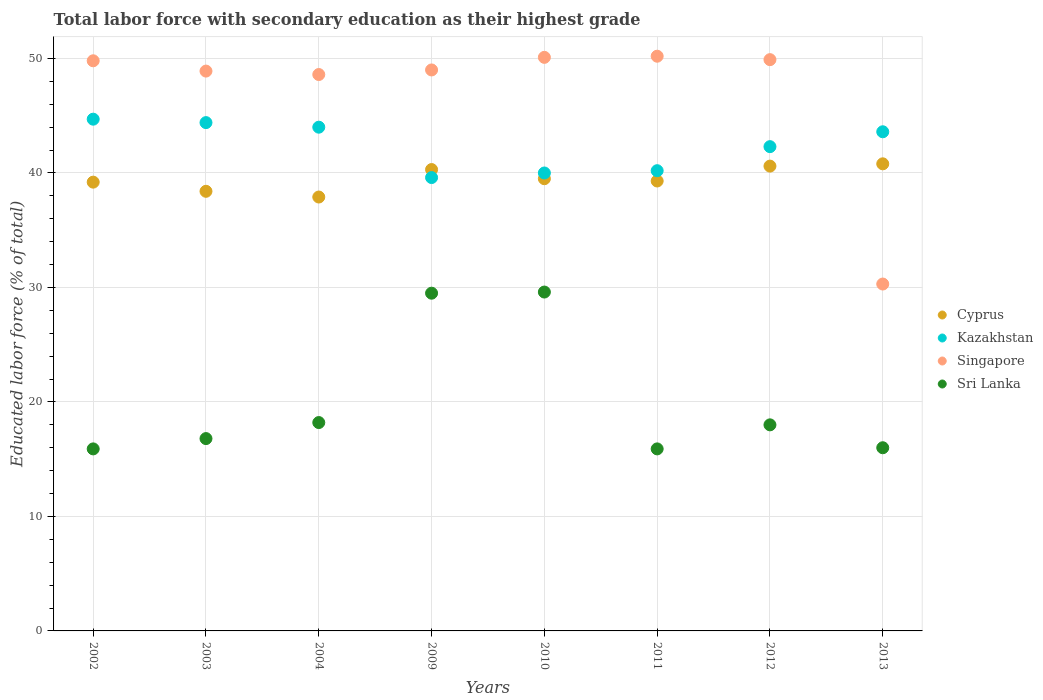How many different coloured dotlines are there?
Provide a short and direct response. 4. Is the number of dotlines equal to the number of legend labels?
Your answer should be very brief. Yes. Across all years, what is the maximum percentage of total labor force with primary education in Singapore?
Ensure brevity in your answer.  50.2. Across all years, what is the minimum percentage of total labor force with primary education in Sri Lanka?
Your answer should be very brief. 15.9. In which year was the percentage of total labor force with primary education in Singapore maximum?
Your response must be concise. 2011. In which year was the percentage of total labor force with primary education in Sri Lanka minimum?
Offer a very short reply. 2002. What is the total percentage of total labor force with primary education in Cyprus in the graph?
Offer a very short reply. 316. What is the difference between the percentage of total labor force with primary education in Cyprus in 2002 and that in 2003?
Offer a very short reply. 0.8. What is the difference between the percentage of total labor force with primary education in Singapore in 2003 and the percentage of total labor force with primary education in Kazakhstan in 2012?
Offer a very short reply. 6.6. What is the average percentage of total labor force with primary education in Kazakhstan per year?
Offer a very short reply. 42.35. In the year 2011, what is the difference between the percentage of total labor force with primary education in Cyprus and percentage of total labor force with primary education in Sri Lanka?
Offer a very short reply. 23.4. In how many years, is the percentage of total labor force with primary education in Sri Lanka greater than 32 %?
Offer a terse response. 0. What is the ratio of the percentage of total labor force with primary education in Sri Lanka in 2002 to that in 2004?
Give a very brief answer. 0.87. Is the percentage of total labor force with primary education in Sri Lanka in 2011 less than that in 2013?
Your answer should be compact. Yes. Is the difference between the percentage of total labor force with primary education in Cyprus in 2002 and 2011 greater than the difference between the percentage of total labor force with primary education in Sri Lanka in 2002 and 2011?
Make the answer very short. No. What is the difference between the highest and the second highest percentage of total labor force with primary education in Cyprus?
Ensure brevity in your answer.  0.2. What is the difference between the highest and the lowest percentage of total labor force with primary education in Sri Lanka?
Your answer should be very brief. 13.7. In how many years, is the percentage of total labor force with primary education in Sri Lanka greater than the average percentage of total labor force with primary education in Sri Lanka taken over all years?
Ensure brevity in your answer.  2. Is it the case that in every year, the sum of the percentage of total labor force with primary education in Singapore and percentage of total labor force with primary education in Kazakhstan  is greater than the percentage of total labor force with primary education in Sri Lanka?
Provide a short and direct response. Yes. Is the percentage of total labor force with primary education in Singapore strictly less than the percentage of total labor force with primary education in Kazakhstan over the years?
Your answer should be very brief. No. How many dotlines are there?
Ensure brevity in your answer.  4. How many years are there in the graph?
Provide a succinct answer. 8. Does the graph contain any zero values?
Your response must be concise. No. How many legend labels are there?
Give a very brief answer. 4. How are the legend labels stacked?
Provide a short and direct response. Vertical. What is the title of the graph?
Your answer should be compact. Total labor force with secondary education as their highest grade. What is the label or title of the Y-axis?
Ensure brevity in your answer.  Educated labor force (% of total). What is the Educated labor force (% of total) in Cyprus in 2002?
Your answer should be compact. 39.2. What is the Educated labor force (% of total) in Kazakhstan in 2002?
Make the answer very short. 44.7. What is the Educated labor force (% of total) in Singapore in 2002?
Offer a terse response. 49.8. What is the Educated labor force (% of total) in Sri Lanka in 2002?
Your response must be concise. 15.9. What is the Educated labor force (% of total) in Cyprus in 2003?
Keep it short and to the point. 38.4. What is the Educated labor force (% of total) in Kazakhstan in 2003?
Your response must be concise. 44.4. What is the Educated labor force (% of total) in Singapore in 2003?
Your answer should be compact. 48.9. What is the Educated labor force (% of total) in Sri Lanka in 2003?
Make the answer very short. 16.8. What is the Educated labor force (% of total) in Cyprus in 2004?
Keep it short and to the point. 37.9. What is the Educated labor force (% of total) in Singapore in 2004?
Your answer should be very brief. 48.6. What is the Educated labor force (% of total) in Sri Lanka in 2004?
Your response must be concise. 18.2. What is the Educated labor force (% of total) in Cyprus in 2009?
Your answer should be very brief. 40.3. What is the Educated labor force (% of total) of Kazakhstan in 2009?
Ensure brevity in your answer.  39.6. What is the Educated labor force (% of total) of Sri Lanka in 2009?
Offer a terse response. 29.5. What is the Educated labor force (% of total) in Cyprus in 2010?
Provide a succinct answer. 39.5. What is the Educated labor force (% of total) of Kazakhstan in 2010?
Your response must be concise. 40. What is the Educated labor force (% of total) in Singapore in 2010?
Keep it short and to the point. 50.1. What is the Educated labor force (% of total) in Sri Lanka in 2010?
Your answer should be very brief. 29.6. What is the Educated labor force (% of total) in Cyprus in 2011?
Provide a short and direct response. 39.3. What is the Educated labor force (% of total) in Kazakhstan in 2011?
Ensure brevity in your answer.  40.2. What is the Educated labor force (% of total) of Singapore in 2011?
Provide a short and direct response. 50.2. What is the Educated labor force (% of total) in Sri Lanka in 2011?
Offer a very short reply. 15.9. What is the Educated labor force (% of total) of Cyprus in 2012?
Ensure brevity in your answer.  40.6. What is the Educated labor force (% of total) in Kazakhstan in 2012?
Provide a short and direct response. 42.3. What is the Educated labor force (% of total) of Singapore in 2012?
Ensure brevity in your answer.  49.9. What is the Educated labor force (% of total) of Cyprus in 2013?
Your answer should be very brief. 40.8. What is the Educated labor force (% of total) in Kazakhstan in 2013?
Offer a very short reply. 43.6. What is the Educated labor force (% of total) in Singapore in 2013?
Your response must be concise. 30.3. Across all years, what is the maximum Educated labor force (% of total) in Cyprus?
Make the answer very short. 40.8. Across all years, what is the maximum Educated labor force (% of total) in Kazakhstan?
Keep it short and to the point. 44.7. Across all years, what is the maximum Educated labor force (% of total) in Singapore?
Your response must be concise. 50.2. Across all years, what is the maximum Educated labor force (% of total) in Sri Lanka?
Give a very brief answer. 29.6. Across all years, what is the minimum Educated labor force (% of total) in Cyprus?
Offer a very short reply. 37.9. Across all years, what is the minimum Educated labor force (% of total) in Kazakhstan?
Make the answer very short. 39.6. Across all years, what is the minimum Educated labor force (% of total) in Singapore?
Your answer should be compact. 30.3. Across all years, what is the minimum Educated labor force (% of total) in Sri Lanka?
Your answer should be compact. 15.9. What is the total Educated labor force (% of total) in Cyprus in the graph?
Your response must be concise. 316. What is the total Educated labor force (% of total) of Kazakhstan in the graph?
Keep it short and to the point. 338.8. What is the total Educated labor force (% of total) of Singapore in the graph?
Your answer should be compact. 376.8. What is the total Educated labor force (% of total) of Sri Lanka in the graph?
Provide a short and direct response. 159.9. What is the difference between the Educated labor force (% of total) of Kazakhstan in 2002 and that in 2003?
Make the answer very short. 0.3. What is the difference between the Educated labor force (% of total) in Sri Lanka in 2002 and that in 2003?
Ensure brevity in your answer.  -0.9. What is the difference between the Educated labor force (% of total) in Cyprus in 2002 and that in 2004?
Provide a succinct answer. 1.3. What is the difference between the Educated labor force (% of total) in Singapore in 2002 and that in 2004?
Provide a succinct answer. 1.2. What is the difference between the Educated labor force (% of total) of Cyprus in 2002 and that in 2009?
Keep it short and to the point. -1.1. What is the difference between the Educated labor force (% of total) of Singapore in 2002 and that in 2009?
Provide a short and direct response. 0.8. What is the difference between the Educated labor force (% of total) of Kazakhstan in 2002 and that in 2010?
Provide a succinct answer. 4.7. What is the difference between the Educated labor force (% of total) in Singapore in 2002 and that in 2010?
Offer a very short reply. -0.3. What is the difference between the Educated labor force (% of total) in Sri Lanka in 2002 and that in 2010?
Your response must be concise. -13.7. What is the difference between the Educated labor force (% of total) of Cyprus in 2002 and that in 2011?
Provide a short and direct response. -0.1. What is the difference between the Educated labor force (% of total) in Kazakhstan in 2002 and that in 2011?
Make the answer very short. 4.5. What is the difference between the Educated labor force (% of total) of Singapore in 2002 and that in 2011?
Your answer should be very brief. -0.4. What is the difference between the Educated labor force (% of total) of Cyprus in 2002 and that in 2013?
Provide a succinct answer. -1.6. What is the difference between the Educated labor force (% of total) in Singapore in 2003 and that in 2004?
Ensure brevity in your answer.  0.3. What is the difference between the Educated labor force (% of total) of Sri Lanka in 2003 and that in 2004?
Your response must be concise. -1.4. What is the difference between the Educated labor force (% of total) of Kazakhstan in 2003 and that in 2009?
Offer a terse response. 4.8. What is the difference between the Educated labor force (% of total) of Kazakhstan in 2003 and that in 2010?
Make the answer very short. 4.4. What is the difference between the Educated labor force (% of total) in Singapore in 2003 and that in 2010?
Your answer should be very brief. -1.2. What is the difference between the Educated labor force (% of total) of Sri Lanka in 2003 and that in 2010?
Keep it short and to the point. -12.8. What is the difference between the Educated labor force (% of total) of Cyprus in 2003 and that in 2011?
Keep it short and to the point. -0.9. What is the difference between the Educated labor force (% of total) of Sri Lanka in 2003 and that in 2011?
Your answer should be very brief. 0.9. What is the difference between the Educated labor force (% of total) in Singapore in 2003 and that in 2012?
Your answer should be compact. -1. What is the difference between the Educated labor force (% of total) of Sri Lanka in 2003 and that in 2012?
Your answer should be very brief. -1.2. What is the difference between the Educated labor force (% of total) of Cyprus in 2004 and that in 2009?
Make the answer very short. -2.4. What is the difference between the Educated labor force (% of total) of Kazakhstan in 2004 and that in 2009?
Give a very brief answer. 4.4. What is the difference between the Educated labor force (% of total) of Singapore in 2004 and that in 2009?
Offer a very short reply. -0.4. What is the difference between the Educated labor force (% of total) in Singapore in 2004 and that in 2010?
Give a very brief answer. -1.5. What is the difference between the Educated labor force (% of total) in Singapore in 2004 and that in 2011?
Keep it short and to the point. -1.6. What is the difference between the Educated labor force (% of total) in Sri Lanka in 2004 and that in 2011?
Your answer should be compact. 2.3. What is the difference between the Educated labor force (% of total) of Singapore in 2004 and that in 2012?
Your answer should be very brief. -1.3. What is the difference between the Educated labor force (% of total) of Sri Lanka in 2004 and that in 2012?
Provide a succinct answer. 0.2. What is the difference between the Educated labor force (% of total) of Cyprus in 2004 and that in 2013?
Give a very brief answer. -2.9. What is the difference between the Educated labor force (% of total) of Singapore in 2004 and that in 2013?
Provide a succinct answer. 18.3. What is the difference between the Educated labor force (% of total) of Singapore in 2009 and that in 2010?
Ensure brevity in your answer.  -1.1. What is the difference between the Educated labor force (% of total) in Kazakhstan in 2009 and that in 2011?
Your answer should be compact. -0.6. What is the difference between the Educated labor force (% of total) in Sri Lanka in 2009 and that in 2011?
Offer a terse response. 13.6. What is the difference between the Educated labor force (% of total) of Cyprus in 2009 and that in 2012?
Offer a very short reply. -0.3. What is the difference between the Educated labor force (% of total) in Kazakhstan in 2009 and that in 2012?
Keep it short and to the point. -2.7. What is the difference between the Educated labor force (% of total) in Cyprus in 2009 and that in 2013?
Provide a succinct answer. -0.5. What is the difference between the Educated labor force (% of total) of Kazakhstan in 2009 and that in 2013?
Your answer should be very brief. -4. What is the difference between the Educated labor force (% of total) in Singapore in 2009 and that in 2013?
Offer a terse response. 18.7. What is the difference between the Educated labor force (% of total) in Sri Lanka in 2009 and that in 2013?
Offer a terse response. 13.5. What is the difference between the Educated labor force (% of total) of Singapore in 2010 and that in 2011?
Give a very brief answer. -0.1. What is the difference between the Educated labor force (% of total) of Kazakhstan in 2010 and that in 2012?
Offer a very short reply. -2.3. What is the difference between the Educated labor force (% of total) in Kazakhstan in 2010 and that in 2013?
Offer a terse response. -3.6. What is the difference between the Educated labor force (% of total) in Singapore in 2010 and that in 2013?
Offer a terse response. 19.8. What is the difference between the Educated labor force (% of total) of Cyprus in 2011 and that in 2012?
Ensure brevity in your answer.  -1.3. What is the difference between the Educated labor force (% of total) in Kazakhstan in 2011 and that in 2012?
Offer a very short reply. -2.1. What is the difference between the Educated labor force (% of total) of Singapore in 2011 and that in 2012?
Your response must be concise. 0.3. What is the difference between the Educated labor force (% of total) in Sri Lanka in 2011 and that in 2012?
Your response must be concise. -2.1. What is the difference between the Educated labor force (% of total) in Kazakhstan in 2011 and that in 2013?
Your answer should be very brief. -3.4. What is the difference between the Educated labor force (% of total) of Singapore in 2011 and that in 2013?
Your answer should be compact. 19.9. What is the difference between the Educated labor force (% of total) of Cyprus in 2012 and that in 2013?
Provide a succinct answer. -0.2. What is the difference between the Educated labor force (% of total) in Kazakhstan in 2012 and that in 2013?
Make the answer very short. -1.3. What is the difference between the Educated labor force (% of total) in Singapore in 2012 and that in 2013?
Your answer should be compact. 19.6. What is the difference between the Educated labor force (% of total) of Sri Lanka in 2012 and that in 2013?
Offer a very short reply. 2. What is the difference between the Educated labor force (% of total) of Cyprus in 2002 and the Educated labor force (% of total) of Kazakhstan in 2003?
Your response must be concise. -5.2. What is the difference between the Educated labor force (% of total) of Cyprus in 2002 and the Educated labor force (% of total) of Singapore in 2003?
Provide a short and direct response. -9.7. What is the difference between the Educated labor force (% of total) in Cyprus in 2002 and the Educated labor force (% of total) in Sri Lanka in 2003?
Give a very brief answer. 22.4. What is the difference between the Educated labor force (% of total) of Kazakhstan in 2002 and the Educated labor force (% of total) of Sri Lanka in 2003?
Make the answer very short. 27.9. What is the difference between the Educated labor force (% of total) of Cyprus in 2002 and the Educated labor force (% of total) of Kazakhstan in 2004?
Make the answer very short. -4.8. What is the difference between the Educated labor force (% of total) of Cyprus in 2002 and the Educated labor force (% of total) of Sri Lanka in 2004?
Keep it short and to the point. 21. What is the difference between the Educated labor force (% of total) of Kazakhstan in 2002 and the Educated labor force (% of total) of Sri Lanka in 2004?
Make the answer very short. 26.5. What is the difference between the Educated labor force (% of total) in Singapore in 2002 and the Educated labor force (% of total) in Sri Lanka in 2004?
Your response must be concise. 31.6. What is the difference between the Educated labor force (% of total) of Cyprus in 2002 and the Educated labor force (% of total) of Kazakhstan in 2009?
Your answer should be very brief. -0.4. What is the difference between the Educated labor force (% of total) of Kazakhstan in 2002 and the Educated labor force (% of total) of Sri Lanka in 2009?
Provide a short and direct response. 15.2. What is the difference between the Educated labor force (% of total) of Singapore in 2002 and the Educated labor force (% of total) of Sri Lanka in 2009?
Provide a succinct answer. 20.3. What is the difference between the Educated labor force (% of total) in Kazakhstan in 2002 and the Educated labor force (% of total) in Singapore in 2010?
Make the answer very short. -5.4. What is the difference between the Educated labor force (% of total) of Singapore in 2002 and the Educated labor force (% of total) of Sri Lanka in 2010?
Provide a short and direct response. 20.2. What is the difference between the Educated labor force (% of total) in Cyprus in 2002 and the Educated labor force (% of total) in Kazakhstan in 2011?
Provide a short and direct response. -1. What is the difference between the Educated labor force (% of total) of Cyprus in 2002 and the Educated labor force (% of total) of Sri Lanka in 2011?
Your answer should be compact. 23.3. What is the difference between the Educated labor force (% of total) of Kazakhstan in 2002 and the Educated labor force (% of total) of Sri Lanka in 2011?
Offer a very short reply. 28.8. What is the difference between the Educated labor force (% of total) of Singapore in 2002 and the Educated labor force (% of total) of Sri Lanka in 2011?
Provide a succinct answer. 33.9. What is the difference between the Educated labor force (% of total) in Cyprus in 2002 and the Educated labor force (% of total) in Sri Lanka in 2012?
Give a very brief answer. 21.2. What is the difference between the Educated labor force (% of total) in Kazakhstan in 2002 and the Educated labor force (% of total) in Sri Lanka in 2012?
Offer a terse response. 26.7. What is the difference between the Educated labor force (% of total) in Singapore in 2002 and the Educated labor force (% of total) in Sri Lanka in 2012?
Make the answer very short. 31.8. What is the difference between the Educated labor force (% of total) in Cyprus in 2002 and the Educated labor force (% of total) in Kazakhstan in 2013?
Provide a succinct answer. -4.4. What is the difference between the Educated labor force (% of total) of Cyprus in 2002 and the Educated labor force (% of total) of Singapore in 2013?
Provide a short and direct response. 8.9. What is the difference between the Educated labor force (% of total) of Cyprus in 2002 and the Educated labor force (% of total) of Sri Lanka in 2013?
Provide a succinct answer. 23.2. What is the difference between the Educated labor force (% of total) of Kazakhstan in 2002 and the Educated labor force (% of total) of Singapore in 2013?
Your response must be concise. 14.4. What is the difference between the Educated labor force (% of total) in Kazakhstan in 2002 and the Educated labor force (% of total) in Sri Lanka in 2013?
Ensure brevity in your answer.  28.7. What is the difference between the Educated labor force (% of total) in Singapore in 2002 and the Educated labor force (% of total) in Sri Lanka in 2013?
Keep it short and to the point. 33.8. What is the difference between the Educated labor force (% of total) of Cyprus in 2003 and the Educated labor force (% of total) of Kazakhstan in 2004?
Your response must be concise. -5.6. What is the difference between the Educated labor force (% of total) in Cyprus in 2003 and the Educated labor force (% of total) in Sri Lanka in 2004?
Offer a terse response. 20.2. What is the difference between the Educated labor force (% of total) in Kazakhstan in 2003 and the Educated labor force (% of total) in Sri Lanka in 2004?
Provide a short and direct response. 26.2. What is the difference between the Educated labor force (% of total) in Singapore in 2003 and the Educated labor force (% of total) in Sri Lanka in 2004?
Provide a succinct answer. 30.7. What is the difference between the Educated labor force (% of total) in Cyprus in 2003 and the Educated labor force (% of total) in Kazakhstan in 2009?
Provide a short and direct response. -1.2. What is the difference between the Educated labor force (% of total) in Cyprus in 2003 and the Educated labor force (% of total) in Singapore in 2009?
Give a very brief answer. -10.6. What is the difference between the Educated labor force (% of total) of Cyprus in 2003 and the Educated labor force (% of total) of Sri Lanka in 2010?
Ensure brevity in your answer.  8.8. What is the difference between the Educated labor force (% of total) in Kazakhstan in 2003 and the Educated labor force (% of total) in Singapore in 2010?
Ensure brevity in your answer.  -5.7. What is the difference between the Educated labor force (% of total) in Singapore in 2003 and the Educated labor force (% of total) in Sri Lanka in 2010?
Your response must be concise. 19.3. What is the difference between the Educated labor force (% of total) of Cyprus in 2003 and the Educated labor force (% of total) of Sri Lanka in 2011?
Offer a very short reply. 22.5. What is the difference between the Educated labor force (% of total) in Kazakhstan in 2003 and the Educated labor force (% of total) in Singapore in 2011?
Your answer should be very brief. -5.8. What is the difference between the Educated labor force (% of total) of Kazakhstan in 2003 and the Educated labor force (% of total) of Sri Lanka in 2011?
Offer a very short reply. 28.5. What is the difference between the Educated labor force (% of total) of Cyprus in 2003 and the Educated labor force (% of total) of Sri Lanka in 2012?
Offer a terse response. 20.4. What is the difference between the Educated labor force (% of total) of Kazakhstan in 2003 and the Educated labor force (% of total) of Singapore in 2012?
Ensure brevity in your answer.  -5.5. What is the difference between the Educated labor force (% of total) in Kazakhstan in 2003 and the Educated labor force (% of total) in Sri Lanka in 2012?
Your answer should be compact. 26.4. What is the difference between the Educated labor force (% of total) of Singapore in 2003 and the Educated labor force (% of total) of Sri Lanka in 2012?
Offer a very short reply. 30.9. What is the difference between the Educated labor force (% of total) in Cyprus in 2003 and the Educated labor force (% of total) in Singapore in 2013?
Provide a succinct answer. 8.1. What is the difference between the Educated labor force (% of total) of Cyprus in 2003 and the Educated labor force (% of total) of Sri Lanka in 2013?
Ensure brevity in your answer.  22.4. What is the difference between the Educated labor force (% of total) in Kazakhstan in 2003 and the Educated labor force (% of total) in Singapore in 2013?
Provide a succinct answer. 14.1. What is the difference between the Educated labor force (% of total) in Kazakhstan in 2003 and the Educated labor force (% of total) in Sri Lanka in 2013?
Your response must be concise. 28.4. What is the difference between the Educated labor force (% of total) in Singapore in 2003 and the Educated labor force (% of total) in Sri Lanka in 2013?
Provide a succinct answer. 32.9. What is the difference between the Educated labor force (% of total) in Cyprus in 2004 and the Educated labor force (% of total) in Kazakhstan in 2009?
Your answer should be very brief. -1.7. What is the difference between the Educated labor force (% of total) of Cyprus in 2004 and the Educated labor force (% of total) of Sri Lanka in 2009?
Your answer should be very brief. 8.4. What is the difference between the Educated labor force (% of total) of Kazakhstan in 2004 and the Educated labor force (% of total) of Singapore in 2009?
Give a very brief answer. -5. What is the difference between the Educated labor force (% of total) in Kazakhstan in 2004 and the Educated labor force (% of total) in Sri Lanka in 2010?
Provide a short and direct response. 14.4. What is the difference between the Educated labor force (% of total) of Singapore in 2004 and the Educated labor force (% of total) of Sri Lanka in 2010?
Offer a very short reply. 19. What is the difference between the Educated labor force (% of total) of Cyprus in 2004 and the Educated labor force (% of total) of Sri Lanka in 2011?
Your answer should be very brief. 22. What is the difference between the Educated labor force (% of total) in Kazakhstan in 2004 and the Educated labor force (% of total) in Sri Lanka in 2011?
Provide a short and direct response. 28.1. What is the difference between the Educated labor force (% of total) in Singapore in 2004 and the Educated labor force (% of total) in Sri Lanka in 2011?
Ensure brevity in your answer.  32.7. What is the difference between the Educated labor force (% of total) of Cyprus in 2004 and the Educated labor force (% of total) of Kazakhstan in 2012?
Ensure brevity in your answer.  -4.4. What is the difference between the Educated labor force (% of total) in Cyprus in 2004 and the Educated labor force (% of total) in Sri Lanka in 2012?
Offer a terse response. 19.9. What is the difference between the Educated labor force (% of total) of Kazakhstan in 2004 and the Educated labor force (% of total) of Singapore in 2012?
Provide a short and direct response. -5.9. What is the difference between the Educated labor force (% of total) of Singapore in 2004 and the Educated labor force (% of total) of Sri Lanka in 2012?
Give a very brief answer. 30.6. What is the difference between the Educated labor force (% of total) in Cyprus in 2004 and the Educated labor force (% of total) in Kazakhstan in 2013?
Give a very brief answer. -5.7. What is the difference between the Educated labor force (% of total) of Cyprus in 2004 and the Educated labor force (% of total) of Sri Lanka in 2013?
Offer a very short reply. 21.9. What is the difference between the Educated labor force (% of total) of Kazakhstan in 2004 and the Educated labor force (% of total) of Singapore in 2013?
Your response must be concise. 13.7. What is the difference between the Educated labor force (% of total) of Singapore in 2004 and the Educated labor force (% of total) of Sri Lanka in 2013?
Offer a very short reply. 32.6. What is the difference between the Educated labor force (% of total) of Cyprus in 2009 and the Educated labor force (% of total) of Singapore in 2010?
Give a very brief answer. -9.8. What is the difference between the Educated labor force (% of total) of Cyprus in 2009 and the Educated labor force (% of total) of Sri Lanka in 2010?
Make the answer very short. 10.7. What is the difference between the Educated labor force (% of total) of Kazakhstan in 2009 and the Educated labor force (% of total) of Sri Lanka in 2010?
Provide a succinct answer. 10. What is the difference between the Educated labor force (% of total) of Cyprus in 2009 and the Educated labor force (% of total) of Sri Lanka in 2011?
Provide a succinct answer. 24.4. What is the difference between the Educated labor force (% of total) of Kazakhstan in 2009 and the Educated labor force (% of total) of Sri Lanka in 2011?
Offer a very short reply. 23.7. What is the difference between the Educated labor force (% of total) of Singapore in 2009 and the Educated labor force (% of total) of Sri Lanka in 2011?
Keep it short and to the point. 33.1. What is the difference between the Educated labor force (% of total) of Cyprus in 2009 and the Educated labor force (% of total) of Sri Lanka in 2012?
Provide a succinct answer. 22.3. What is the difference between the Educated labor force (% of total) in Kazakhstan in 2009 and the Educated labor force (% of total) in Singapore in 2012?
Provide a succinct answer. -10.3. What is the difference between the Educated labor force (% of total) in Kazakhstan in 2009 and the Educated labor force (% of total) in Sri Lanka in 2012?
Offer a very short reply. 21.6. What is the difference between the Educated labor force (% of total) in Cyprus in 2009 and the Educated labor force (% of total) in Kazakhstan in 2013?
Provide a short and direct response. -3.3. What is the difference between the Educated labor force (% of total) of Cyprus in 2009 and the Educated labor force (% of total) of Sri Lanka in 2013?
Make the answer very short. 24.3. What is the difference between the Educated labor force (% of total) of Kazakhstan in 2009 and the Educated labor force (% of total) of Sri Lanka in 2013?
Your answer should be compact. 23.6. What is the difference between the Educated labor force (% of total) of Cyprus in 2010 and the Educated labor force (% of total) of Kazakhstan in 2011?
Provide a short and direct response. -0.7. What is the difference between the Educated labor force (% of total) in Cyprus in 2010 and the Educated labor force (% of total) in Sri Lanka in 2011?
Ensure brevity in your answer.  23.6. What is the difference between the Educated labor force (% of total) in Kazakhstan in 2010 and the Educated labor force (% of total) in Sri Lanka in 2011?
Keep it short and to the point. 24.1. What is the difference between the Educated labor force (% of total) of Singapore in 2010 and the Educated labor force (% of total) of Sri Lanka in 2011?
Your response must be concise. 34.2. What is the difference between the Educated labor force (% of total) of Cyprus in 2010 and the Educated labor force (% of total) of Kazakhstan in 2012?
Offer a very short reply. -2.8. What is the difference between the Educated labor force (% of total) of Cyprus in 2010 and the Educated labor force (% of total) of Singapore in 2012?
Offer a terse response. -10.4. What is the difference between the Educated labor force (% of total) in Cyprus in 2010 and the Educated labor force (% of total) in Sri Lanka in 2012?
Your response must be concise. 21.5. What is the difference between the Educated labor force (% of total) of Kazakhstan in 2010 and the Educated labor force (% of total) of Singapore in 2012?
Keep it short and to the point. -9.9. What is the difference between the Educated labor force (% of total) in Singapore in 2010 and the Educated labor force (% of total) in Sri Lanka in 2012?
Ensure brevity in your answer.  32.1. What is the difference between the Educated labor force (% of total) of Cyprus in 2010 and the Educated labor force (% of total) of Kazakhstan in 2013?
Ensure brevity in your answer.  -4.1. What is the difference between the Educated labor force (% of total) in Cyprus in 2010 and the Educated labor force (% of total) in Singapore in 2013?
Provide a short and direct response. 9.2. What is the difference between the Educated labor force (% of total) of Cyprus in 2010 and the Educated labor force (% of total) of Sri Lanka in 2013?
Offer a very short reply. 23.5. What is the difference between the Educated labor force (% of total) in Kazakhstan in 2010 and the Educated labor force (% of total) in Singapore in 2013?
Your answer should be very brief. 9.7. What is the difference between the Educated labor force (% of total) in Singapore in 2010 and the Educated labor force (% of total) in Sri Lanka in 2013?
Offer a very short reply. 34.1. What is the difference between the Educated labor force (% of total) of Cyprus in 2011 and the Educated labor force (% of total) of Kazakhstan in 2012?
Ensure brevity in your answer.  -3. What is the difference between the Educated labor force (% of total) of Cyprus in 2011 and the Educated labor force (% of total) of Singapore in 2012?
Offer a very short reply. -10.6. What is the difference between the Educated labor force (% of total) of Cyprus in 2011 and the Educated labor force (% of total) of Sri Lanka in 2012?
Keep it short and to the point. 21.3. What is the difference between the Educated labor force (% of total) in Kazakhstan in 2011 and the Educated labor force (% of total) in Singapore in 2012?
Ensure brevity in your answer.  -9.7. What is the difference between the Educated labor force (% of total) in Singapore in 2011 and the Educated labor force (% of total) in Sri Lanka in 2012?
Your response must be concise. 32.2. What is the difference between the Educated labor force (% of total) of Cyprus in 2011 and the Educated labor force (% of total) of Kazakhstan in 2013?
Provide a succinct answer. -4.3. What is the difference between the Educated labor force (% of total) in Cyprus in 2011 and the Educated labor force (% of total) in Sri Lanka in 2013?
Provide a short and direct response. 23.3. What is the difference between the Educated labor force (% of total) of Kazakhstan in 2011 and the Educated labor force (% of total) of Sri Lanka in 2013?
Give a very brief answer. 24.2. What is the difference between the Educated labor force (% of total) in Singapore in 2011 and the Educated labor force (% of total) in Sri Lanka in 2013?
Your response must be concise. 34.2. What is the difference between the Educated labor force (% of total) in Cyprus in 2012 and the Educated labor force (% of total) in Sri Lanka in 2013?
Ensure brevity in your answer.  24.6. What is the difference between the Educated labor force (% of total) in Kazakhstan in 2012 and the Educated labor force (% of total) in Sri Lanka in 2013?
Offer a very short reply. 26.3. What is the difference between the Educated labor force (% of total) of Singapore in 2012 and the Educated labor force (% of total) of Sri Lanka in 2013?
Your answer should be compact. 33.9. What is the average Educated labor force (% of total) of Cyprus per year?
Offer a very short reply. 39.5. What is the average Educated labor force (% of total) of Kazakhstan per year?
Your answer should be very brief. 42.35. What is the average Educated labor force (% of total) in Singapore per year?
Make the answer very short. 47.1. What is the average Educated labor force (% of total) of Sri Lanka per year?
Keep it short and to the point. 19.99. In the year 2002, what is the difference between the Educated labor force (% of total) in Cyprus and Educated labor force (% of total) in Kazakhstan?
Give a very brief answer. -5.5. In the year 2002, what is the difference between the Educated labor force (% of total) of Cyprus and Educated labor force (% of total) of Singapore?
Ensure brevity in your answer.  -10.6. In the year 2002, what is the difference between the Educated labor force (% of total) in Cyprus and Educated labor force (% of total) in Sri Lanka?
Give a very brief answer. 23.3. In the year 2002, what is the difference between the Educated labor force (% of total) in Kazakhstan and Educated labor force (% of total) in Sri Lanka?
Provide a short and direct response. 28.8. In the year 2002, what is the difference between the Educated labor force (% of total) in Singapore and Educated labor force (% of total) in Sri Lanka?
Your response must be concise. 33.9. In the year 2003, what is the difference between the Educated labor force (% of total) of Cyprus and Educated labor force (% of total) of Singapore?
Provide a succinct answer. -10.5. In the year 2003, what is the difference between the Educated labor force (% of total) of Cyprus and Educated labor force (% of total) of Sri Lanka?
Your answer should be compact. 21.6. In the year 2003, what is the difference between the Educated labor force (% of total) in Kazakhstan and Educated labor force (% of total) in Sri Lanka?
Provide a short and direct response. 27.6. In the year 2003, what is the difference between the Educated labor force (% of total) in Singapore and Educated labor force (% of total) in Sri Lanka?
Make the answer very short. 32.1. In the year 2004, what is the difference between the Educated labor force (% of total) of Cyprus and Educated labor force (% of total) of Singapore?
Your answer should be very brief. -10.7. In the year 2004, what is the difference between the Educated labor force (% of total) of Cyprus and Educated labor force (% of total) of Sri Lanka?
Provide a succinct answer. 19.7. In the year 2004, what is the difference between the Educated labor force (% of total) of Kazakhstan and Educated labor force (% of total) of Singapore?
Offer a terse response. -4.6. In the year 2004, what is the difference between the Educated labor force (% of total) of Kazakhstan and Educated labor force (% of total) of Sri Lanka?
Give a very brief answer. 25.8. In the year 2004, what is the difference between the Educated labor force (% of total) of Singapore and Educated labor force (% of total) of Sri Lanka?
Make the answer very short. 30.4. In the year 2009, what is the difference between the Educated labor force (% of total) of Cyprus and Educated labor force (% of total) of Kazakhstan?
Provide a short and direct response. 0.7. In the year 2009, what is the difference between the Educated labor force (% of total) of Kazakhstan and Educated labor force (% of total) of Singapore?
Your answer should be compact. -9.4. In the year 2009, what is the difference between the Educated labor force (% of total) in Kazakhstan and Educated labor force (% of total) in Sri Lanka?
Keep it short and to the point. 10.1. In the year 2009, what is the difference between the Educated labor force (% of total) of Singapore and Educated labor force (% of total) of Sri Lanka?
Offer a very short reply. 19.5. In the year 2010, what is the difference between the Educated labor force (% of total) of Cyprus and Educated labor force (% of total) of Sri Lanka?
Keep it short and to the point. 9.9. In the year 2010, what is the difference between the Educated labor force (% of total) of Kazakhstan and Educated labor force (% of total) of Singapore?
Provide a short and direct response. -10.1. In the year 2010, what is the difference between the Educated labor force (% of total) in Singapore and Educated labor force (% of total) in Sri Lanka?
Keep it short and to the point. 20.5. In the year 2011, what is the difference between the Educated labor force (% of total) of Cyprus and Educated labor force (% of total) of Singapore?
Provide a short and direct response. -10.9. In the year 2011, what is the difference between the Educated labor force (% of total) of Cyprus and Educated labor force (% of total) of Sri Lanka?
Your answer should be very brief. 23.4. In the year 2011, what is the difference between the Educated labor force (% of total) of Kazakhstan and Educated labor force (% of total) of Sri Lanka?
Give a very brief answer. 24.3. In the year 2011, what is the difference between the Educated labor force (% of total) in Singapore and Educated labor force (% of total) in Sri Lanka?
Your answer should be compact. 34.3. In the year 2012, what is the difference between the Educated labor force (% of total) of Cyprus and Educated labor force (% of total) of Kazakhstan?
Give a very brief answer. -1.7. In the year 2012, what is the difference between the Educated labor force (% of total) of Cyprus and Educated labor force (% of total) of Singapore?
Give a very brief answer. -9.3. In the year 2012, what is the difference between the Educated labor force (% of total) of Cyprus and Educated labor force (% of total) of Sri Lanka?
Ensure brevity in your answer.  22.6. In the year 2012, what is the difference between the Educated labor force (% of total) of Kazakhstan and Educated labor force (% of total) of Singapore?
Give a very brief answer. -7.6. In the year 2012, what is the difference between the Educated labor force (% of total) in Kazakhstan and Educated labor force (% of total) in Sri Lanka?
Your answer should be compact. 24.3. In the year 2012, what is the difference between the Educated labor force (% of total) in Singapore and Educated labor force (% of total) in Sri Lanka?
Offer a very short reply. 31.9. In the year 2013, what is the difference between the Educated labor force (% of total) of Cyprus and Educated labor force (% of total) of Kazakhstan?
Keep it short and to the point. -2.8. In the year 2013, what is the difference between the Educated labor force (% of total) in Cyprus and Educated labor force (% of total) in Sri Lanka?
Provide a short and direct response. 24.8. In the year 2013, what is the difference between the Educated labor force (% of total) of Kazakhstan and Educated labor force (% of total) of Sri Lanka?
Give a very brief answer. 27.6. In the year 2013, what is the difference between the Educated labor force (% of total) in Singapore and Educated labor force (% of total) in Sri Lanka?
Give a very brief answer. 14.3. What is the ratio of the Educated labor force (% of total) in Cyprus in 2002 to that in 2003?
Your answer should be compact. 1.02. What is the ratio of the Educated labor force (% of total) of Kazakhstan in 2002 to that in 2003?
Make the answer very short. 1.01. What is the ratio of the Educated labor force (% of total) in Singapore in 2002 to that in 2003?
Provide a succinct answer. 1.02. What is the ratio of the Educated labor force (% of total) of Sri Lanka in 2002 to that in 2003?
Offer a terse response. 0.95. What is the ratio of the Educated labor force (% of total) in Cyprus in 2002 to that in 2004?
Make the answer very short. 1.03. What is the ratio of the Educated labor force (% of total) in Kazakhstan in 2002 to that in 2004?
Provide a succinct answer. 1.02. What is the ratio of the Educated labor force (% of total) of Singapore in 2002 to that in 2004?
Keep it short and to the point. 1.02. What is the ratio of the Educated labor force (% of total) in Sri Lanka in 2002 to that in 2004?
Offer a terse response. 0.87. What is the ratio of the Educated labor force (% of total) of Cyprus in 2002 to that in 2009?
Provide a short and direct response. 0.97. What is the ratio of the Educated labor force (% of total) in Kazakhstan in 2002 to that in 2009?
Provide a short and direct response. 1.13. What is the ratio of the Educated labor force (% of total) of Singapore in 2002 to that in 2009?
Your answer should be compact. 1.02. What is the ratio of the Educated labor force (% of total) in Sri Lanka in 2002 to that in 2009?
Offer a very short reply. 0.54. What is the ratio of the Educated labor force (% of total) in Cyprus in 2002 to that in 2010?
Make the answer very short. 0.99. What is the ratio of the Educated labor force (% of total) in Kazakhstan in 2002 to that in 2010?
Ensure brevity in your answer.  1.12. What is the ratio of the Educated labor force (% of total) of Singapore in 2002 to that in 2010?
Your answer should be compact. 0.99. What is the ratio of the Educated labor force (% of total) of Sri Lanka in 2002 to that in 2010?
Your answer should be compact. 0.54. What is the ratio of the Educated labor force (% of total) in Kazakhstan in 2002 to that in 2011?
Your answer should be very brief. 1.11. What is the ratio of the Educated labor force (% of total) in Singapore in 2002 to that in 2011?
Offer a very short reply. 0.99. What is the ratio of the Educated labor force (% of total) of Cyprus in 2002 to that in 2012?
Your answer should be very brief. 0.97. What is the ratio of the Educated labor force (% of total) in Kazakhstan in 2002 to that in 2012?
Provide a short and direct response. 1.06. What is the ratio of the Educated labor force (% of total) in Sri Lanka in 2002 to that in 2012?
Provide a succinct answer. 0.88. What is the ratio of the Educated labor force (% of total) in Cyprus in 2002 to that in 2013?
Keep it short and to the point. 0.96. What is the ratio of the Educated labor force (% of total) in Kazakhstan in 2002 to that in 2013?
Your answer should be compact. 1.03. What is the ratio of the Educated labor force (% of total) in Singapore in 2002 to that in 2013?
Keep it short and to the point. 1.64. What is the ratio of the Educated labor force (% of total) in Sri Lanka in 2002 to that in 2013?
Offer a terse response. 0.99. What is the ratio of the Educated labor force (% of total) of Cyprus in 2003 to that in 2004?
Make the answer very short. 1.01. What is the ratio of the Educated labor force (% of total) in Kazakhstan in 2003 to that in 2004?
Keep it short and to the point. 1.01. What is the ratio of the Educated labor force (% of total) of Singapore in 2003 to that in 2004?
Give a very brief answer. 1.01. What is the ratio of the Educated labor force (% of total) in Sri Lanka in 2003 to that in 2004?
Ensure brevity in your answer.  0.92. What is the ratio of the Educated labor force (% of total) in Cyprus in 2003 to that in 2009?
Give a very brief answer. 0.95. What is the ratio of the Educated labor force (% of total) of Kazakhstan in 2003 to that in 2009?
Offer a terse response. 1.12. What is the ratio of the Educated labor force (% of total) in Singapore in 2003 to that in 2009?
Provide a short and direct response. 1. What is the ratio of the Educated labor force (% of total) in Sri Lanka in 2003 to that in 2009?
Give a very brief answer. 0.57. What is the ratio of the Educated labor force (% of total) in Cyprus in 2003 to that in 2010?
Offer a very short reply. 0.97. What is the ratio of the Educated labor force (% of total) in Kazakhstan in 2003 to that in 2010?
Your answer should be compact. 1.11. What is the ratio of the Educated labor force (% of total) of Singapore in 2003 to that in 2010?
Your answer should be very brief. 0.98. What is the ratio of the Educated labor force (% of total) in Sri Lanka in 2003 to that in 2010?
Provide a succinct answer. 0.57. What is the ratio of the Educated labor force (% of total) in Cyprus in 2003 to that in 2011?
Provide a short and direct response. 0.98. What is the ratio of the Educated labor force (% of total) in Kazakhstan in 2003 to that in 2011?
Give a very brief answer. 1.1. What is the ratio of the Educated labor force (% of total) of Singapore in 2003 to that in 2011?
Your answer should be compact. 0.97. What is the ratio of the Educated labor force (% of total) in Sri Lanka in 2003 to that in 2011?
Ensure brevity in your answer.  1.06. What is the ratio of the Educated labor force (% of total) in Cyprus in 2003 to that in 2012?
Your answer should be compact. 0.95. What is the ratio of the Educated labor force (% of total) in Kazakhstan in 2003 to that in 2012?
Your response must be concise. 1.05. What is the ratio of the Educated labor force (% of total) of Cyprus in 2003 to that in 2013?
Provide a succinct answer. 0.94. What is the ratio of the Educated labor force (% of total) in Kazakhstan in 2003 to that in 2013?
Your answer should be very brief. 1.02. What is the ratio of the Educated labor force (% of total) of Singapore in 2003 to that in 2013?
Your answer should be compact. 1.61. What is the ratio of the Educated labor force (% of total) in Sri Lanka in 2003 to that in 2013?
Offer a very short reply. 1.05. What is the ratio of the Educated labor force (% of total) of Cyprus in 2004 to that in 2009?
Make the answer very short. 0.94. What is the ratio of the Educated labor force (% of total) in Singapore in 2004 to that in 2009?
Your answer should be very brief. 0.99. What is the ratio of the Educated labor force (% of total) of Sri Lanka in 2004 to that in 2009?
Ensure brevity in your answer.  0.62. What is the ratio of the Educated labor force (% of total) in Cyprus in 2004 to that in 2010?
Provide a short and direct response. 0.96. What is the ratio of the Educated labor force (% of total) of Singapore in 2004 to that in 2010?
Give a very brief answer. 0.97. What is the ratio of the Educated labor force (% of total) of Sri Lanka in 2004 to that in 2010?
Keep it short and to the point. 0.61. What is the ratio of the Educated labor force (% of total) in Cyprus in 2004 to that in 2011?
Your response must be concise. 0.96. What is the ratio of the Educated labor force (% of total) of Kazakhstan in 2004 to that in 2011?
Provide a short and direct response. 1.09. What is the ratio of the Educated labor force (% of total) of Singapore in 2004 to that in 2011?
Your response must be concise. 0.97. What is the ratio of the Educated labor force (% of total) in Sri Lanka in 2004 to that in 2011?
Your answer should be very brief. 1.14. What is the ratio of the Educated labor force (% of total) of Cyprus in 2004 to that in 2012?
Your response must be concise. 0.93. What is the ratio of the Educated labor force (% of total) of Kazakhstan in 2004 to that in 2012?
Your response must be concise. 1.04. What is the ratio of the Educated labor force (% of total) in Singapore in 2004 to that in 2012?
Provide a succinct answer. 0.97. What is the ratio of the Educated labor force (% of total) of Sri Lanka in 2004 to that in 2012?
Provide a short and direct response. 1.01. What is the ratio of the Educated labor force (% of total) in Cyprus in 2004 to that in 2013?
Offer a very short reply. 0.93. What is the ratio of the Educated labor force (% of total) in Kazakhstan in 2004 to that in 2013?
Provide a succinct answer. 1.01. What is the ratio of the Educated labor force (% of total) in Singapore in 2004 to that in 2013?
Offer a terse response. 1.6. What is the ratio of the Educated labor force (% of total) in Sri Lanka in 2004 to that in 2013?
Provide a succinct answer. 1.14. What is the ratio of the Educated labor force (% of total) of Cyprus in 2009 to that in 2010?
Ensure brevity in your answer.  1.02. What is the ratio of the Educated labor force (% of total) of Kazakhstan in 2009 to that in 2010?
Keep it short and to the point. 0.99. What is the ratio of the Educated labor force (% of total) in Cyprus in 2009 to that in 2011?
Offer a very short reply. 1.03. What is the ratio of the Educated labor force (% of total) in Kazakhstan in 2009 to that in 2011?
Your response must be concise. 0.99. What is the ratio of the Educated labor force (% of total) of Singapore in 2009 to that in 2011?
Keep it short and to the point. 0.98. What is the ratio of the Educated labor force (% of total) in Sri Lanka in 2009 to that in 2011?
Keep it short and to the point. 1.86. What is the ratio of the Educated labor force (% of total) of Kazakhstan in 2009 to that in 2012?
Ensure brevity in your answer.  0.94. What is the ratio of the Educated labor force (% of total) in Sri Lanka in 2009 to that in 2012?
Offer a very short reply. 1.64. What is the ratio of the Educated labor force (% of total) in Cyprus in 2009 to that in 2013?
Ensure brevity in your answer.  0.99. What is the ratio of the Educated labor force (% of total) of Kazakhstan in 2009 to that in 2013?
Give a very brief answer. 0.91. What is the ratio of the Educated labor force (% of total) in Singapore in 2009 to that in 2013?
Your response must be concise. 1.62. What is the ratio of the Educated labor force (% of total) of Sri Lanka in 2009 to that in 2013?
Give a very brief answer. 1.84. What is the ratio of the Educated labor force (% of total) in Cyprus in 2010 to that in 2011?
Ensure brevity in your answer.  1.01. What is the ratio of the Educated labor force (% of total) in Singapore in 2010 to that in 2011?
Provide a short and direct response. 1. What is the ratio of the Educated labor force (% of total) in Sri Lanka in 2010 to that in 2011?
Provide a succinct answer. 1.86. What is the ratio of the Educated labor force (% of total) in Cyprus in 2010 to that in 2012?
Your answer should be compact. 0.97. What is the ratio of the Educated labor force (% of total) in Kazakhstan in 2010 to that in 2012?
Your answer should be very brief. 0.95. What is the ratio of the Educated labor force (% of total) in Sri Lanka in 2010 to that in 2012?
Your response must be concise. 1.64. What is the ratio of the Educated labor force (% of total) in Cyprus in 2010 to that in 2013?
Make the answer very short. 0.97. What is the ratio of the Educated labor force (% of total) in Kazakhstan in 2010 to that in 2013?
Give a very brief answer. 0.92. What is the ratio of the Educated labor force (% of total) of Singapore in 2010 to that in 2013?
Provide a succinct answer. 1.65. What is the ratio of the Educated labor force (% of total) in Sri Lanka in 2010 to that in 2013?
Provide a succinct answer. 1.85. What is the ratio of the Educated labor force (% of total) of Cyprus in 2011 to that in 2012?
Provide a succinct answer. 0.97. What is the ratio of the Educated labor force (% of total) in Kazakhstan in 2011 to that in 2012?
Provide a short and direct response. 0.95. What is the ratio of the Educated labor force (% of total) of Sri Lanka in 2011 to that in 2012?
Make the answer very short. 0.88. What is the ratio of the Educated labor force (% of total) of Cyprus in 2011 to that in 2013?
Your response must be concise. 0.96. What is the ratio of the Educated labor force (% of total) of Kazakhstan in 2011 to that in 2013?
Ensure brevity in your answer.  0.92. What is the ratio of the Educated labor force (% of total) in Singapore in 2011 to that in 2013?
Your response must be concise. 1.66. What is the ratio of the Educated labor force (% of total) in Kazakhstan in 2012 to that in 2013?
Your answer should be compact. 0.97. What is the ratio of the Educated labor force (% of total) of Singapore in 2012 to that in 2013?
Keep it short and to the point. 1.65. What is the difference between the highest and the second highest Educated labor force (% of total) in Sri Lanka?
Provide a succinct answer. 0.1. What is the difference between the highest and the lowest Educated labor force (% of total) in Cyprus?
Your answer should be compact. 2.9. What is the difference between the highest and the lowest Educated labor force (% of total) of Singapore?
Provide a succinct answer. 19.9. 